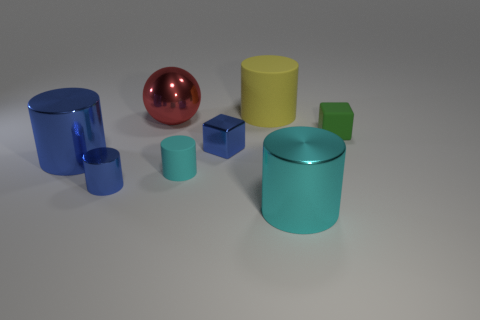Subtract all large blue cylinders. How many cylinders are left? 4 Subtract all gray spheres. How many cyan cylinders are left? 2 Add 1 tiny cyan shiny balls. How many objects exist? 9 Subtract all blue cubes. How many cubes are left? 1 Subtract 1 cylinders. How many cylinders are left? 4 Subtract all red objects. Subtract all big red balls. How many objects are left? 6 Add 3 small blocks. How many small blocks are left? 5 Add 5 tiny green rubber things. How many tiny green rubber things exist? 6 Subtract 0 yellow spheres. How many objects are left? 8 Subtract all cylinders. How many objects are left? 3 